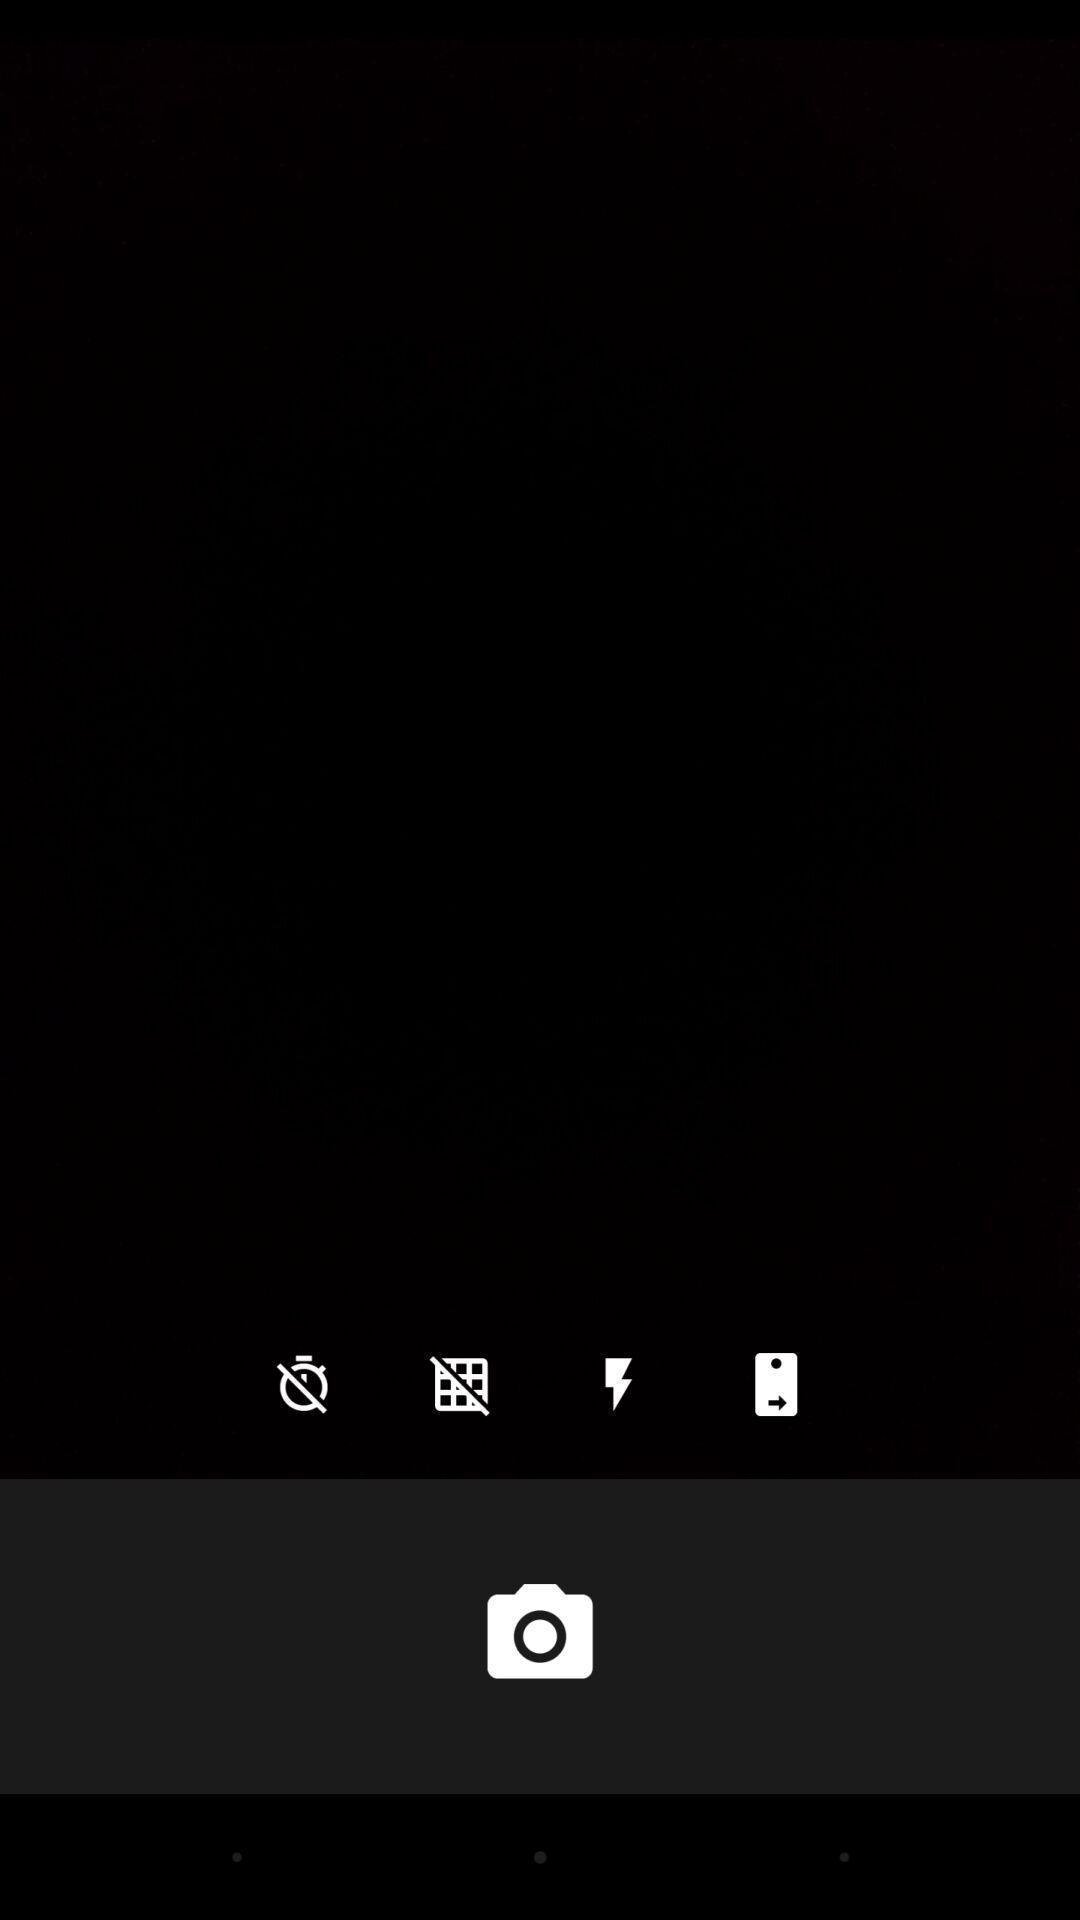Give me a summary of this screen capture. Page displaying camera icon. 